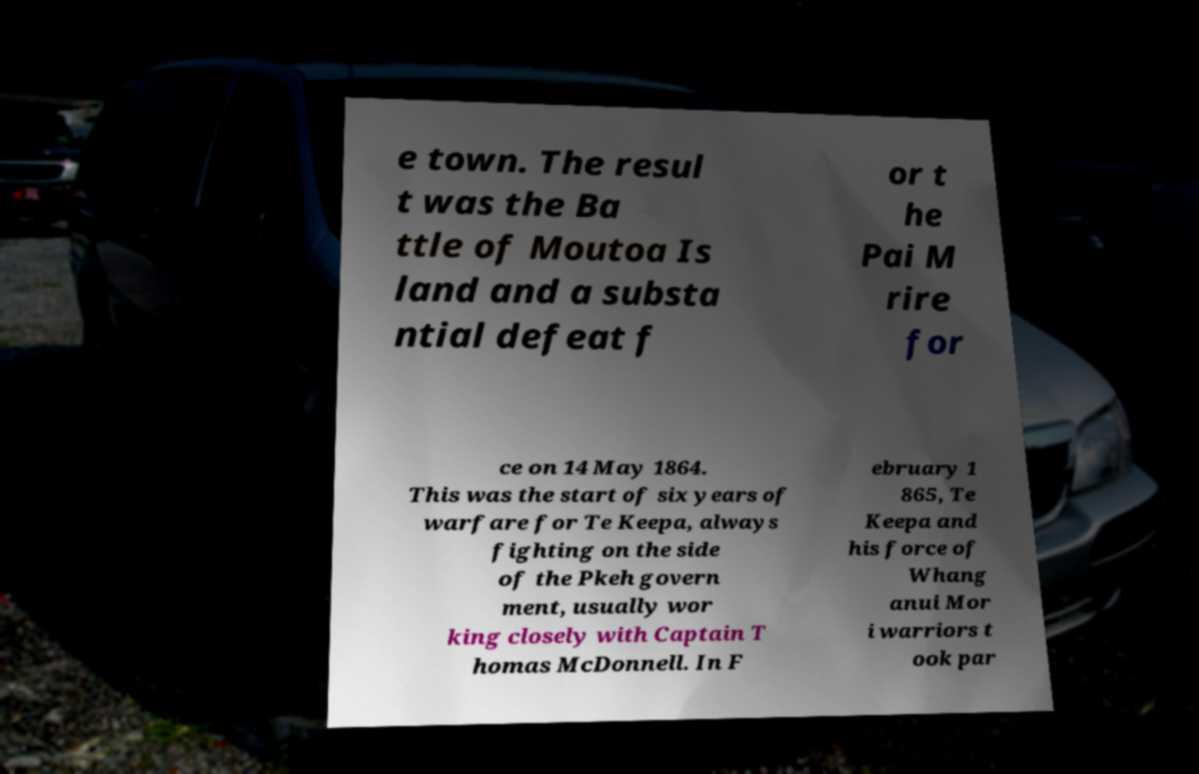Can you accurately transcribe the text from the provided image for me? e town. The resul t was the Ba ttle of Moutoa Is land and a substa ntial defeat f or t he Pai M rire for ce on 14 May 1864. This was the start of six years of warfare for Te Keepa, always fighting on the side of the Pkeh govern ment, usually wor king closely with Captain T homas McDonnell. In F ebruary 1 865, Te Keepa and his force of Whang anui Mor i warriors t ook par 